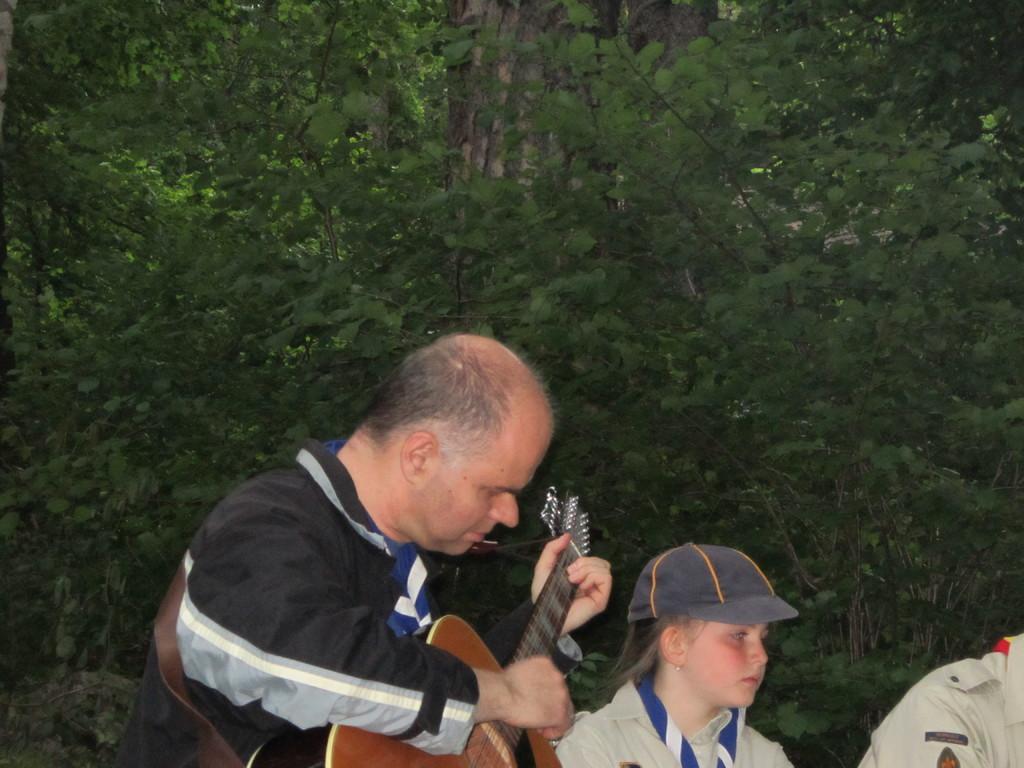Could you give a brief overview of what you see in this image? A man is playing a guitar. Beside him there is a girl wearing a cap. 